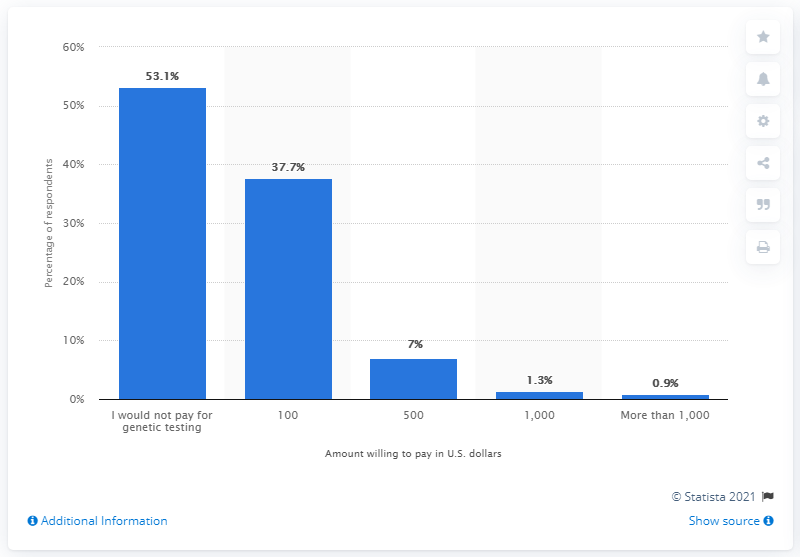What did 37.7 percent of Americans say they would pay for genetic testing? According to the bar chart, 37.7 percent of Americans indicated that they would be willing to pay $100 for genetic testing. 